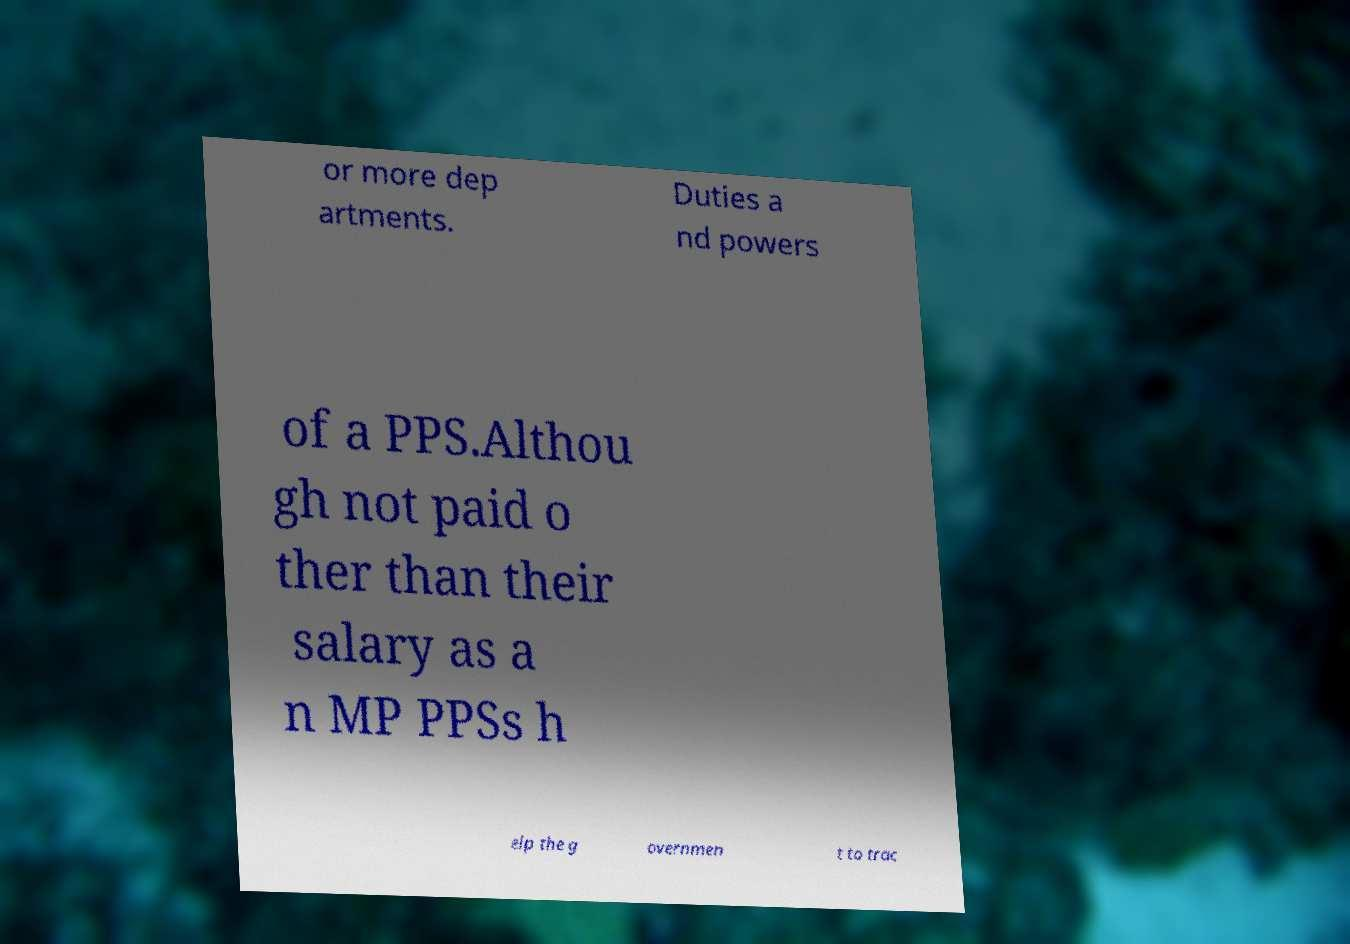Can you accurately transcribe the text from the provided image for me? or more dep artments. Duties a nd powers of a PPS.Althou gh not paid o ther than their salary as a n MP PPSs h elp the g overnmen t to trac 